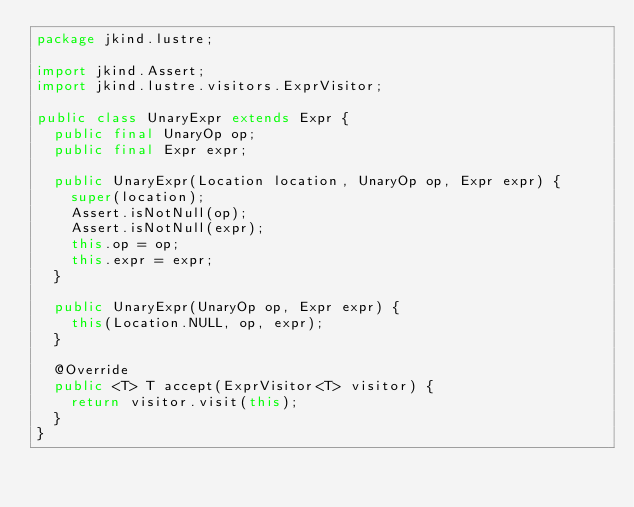Convert code to text. <code><loc_0><loc_0><loc_500><loc_500><_Java_>package jkind.lustre;

import jkind.Assert;
import jkind.lustre.visitors.ExprVisitor;

public class UnaryExpr extends Expr {
	public final UnaryOp op;
	public final Expr expr;

	public UnaryExpr(Location location, UnaryOp op, Expr expr) {
		super(location);
		Assert.isNotNull(op);
		Assert.isNotNull(expr);
		this.op = op;
		this.expr = expr;
	}
	
	public UnaryExpr(UnaryOp op, Expr expr) {
		this(Location.NULL, op, expr);
	}
	
	@Override
	public <T> T accept(ExprVisitor<T> visitor) {
		return visitor.visit(this);
	}
}
</code> 